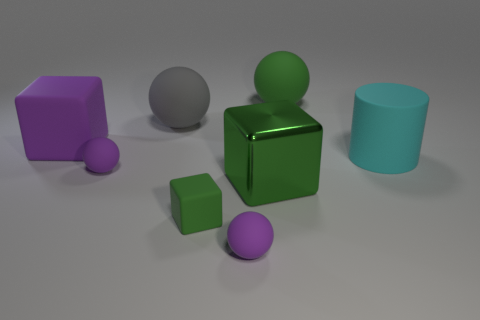What is the material of the tiny green block?
Offer a very short reply. Rubber. There is a large green thing that is the same material as the big gray object; what shape is it?
Offer a terse response. Sphere. There is a rubber thing to the right of the big green thing behind the large purple thing; what size is it?
Your response must be concise. Large. There is a rubber sphere to the right of the large green block; what is its color?
Your answer should be very brief. Green. Are there any green objects of the same shape as the big purple object?
Offer a very short reply. Yes. Is the number of objects behind the matte cylinder less than the number of rubber things behind the green metal object?
Make the answer very short. Yes. The metal thing is what color?
Your answer should be compact. Green. There is a green thing behind the cylinder; is there a big sphere in front of it?
Your response must be concise. Yes. How many purple shiny things have the same size as the green metal cube?
Keep it short and to the point. 0. What number of purple matte things are right of the green matte object in front of the big purple rubber block that is behind the cylinder?
Your response must be concise. 1. 